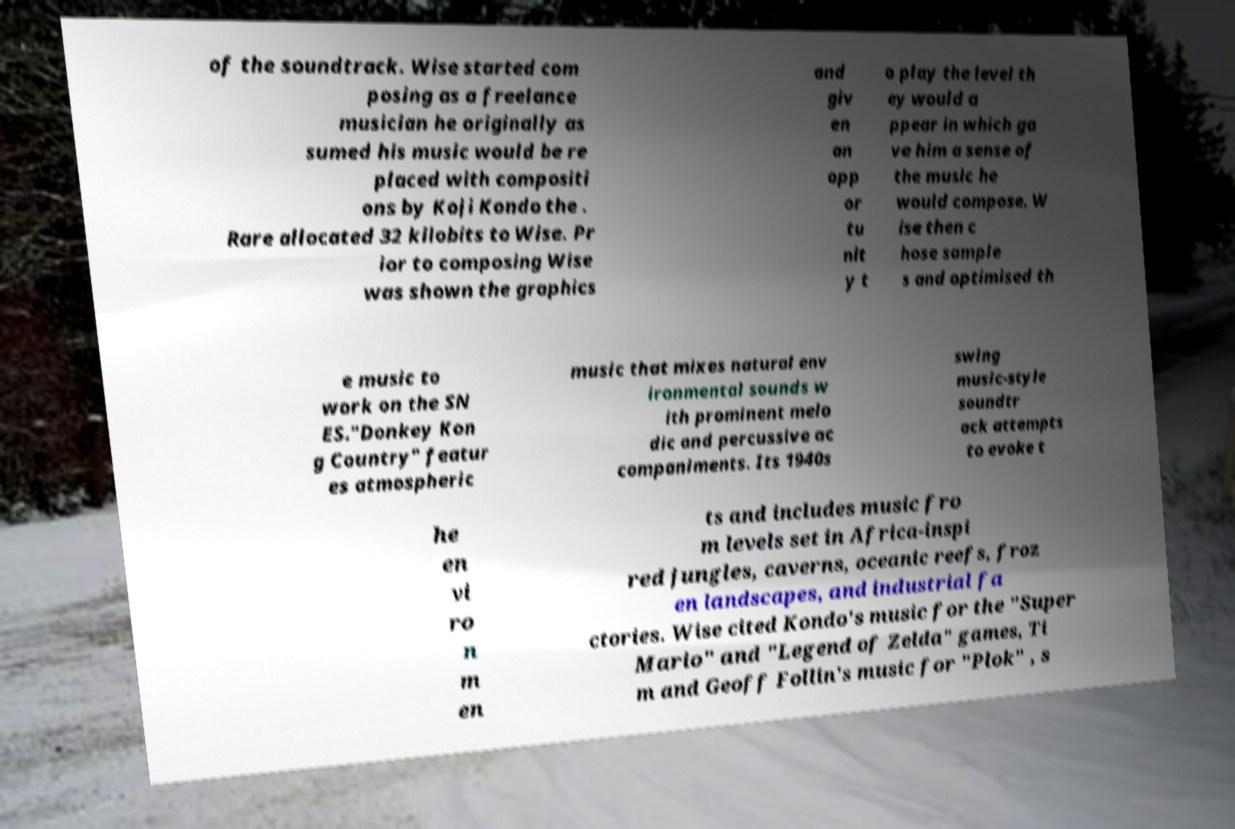For documentation purposes, I need the text within this image transcribed. Could you provide that? of the soundtrack. Wise started com posing as a freelance musician he originally as sumed his music would be re placed with compositi ons by Koji Kondo the . Rare allocated 32 kilobits to Wise. Pr ior to composing Wise was shown the graphics and giv en an opp or tu nit y t o play the level th ey would a ppear in which ga ve him a sense of the music he would compose. W ise then c hose sample s and optimised th e music to work on the SN ES."Donkey Kon g Country" featur es atmospheric music that mixes natural env ironmental sounds w ith prominent melo dic and percussive ac companiments. Its 1940s swing music-style soundtr ack attempts to evoke t he en vi ro n m en ts and includes music fro m levels set in Africa-inspi red jungles, caverns, oceanic reefs, froz en landscapes, and industrial fa ctories. Wise cited Kondo's music for the "Super Mario" and "Legend of Zelda" games, Ti m and Geoff Follin's music for "Plok" , s 